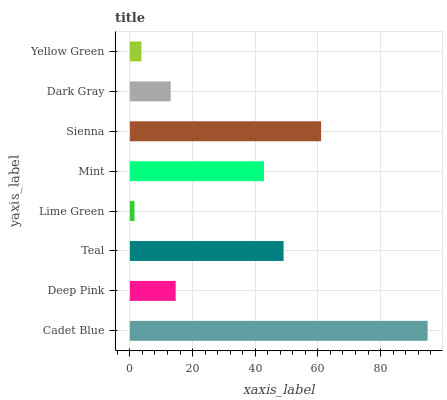Is Lime Green the minimum?
Answer yes or no. Yes. Is Cadet Blue the maximum?
Answer yes or no. Yes. Is Deep Pink the minimum?
Answer yes or no. No. Is Deep Pink the maximum?
Answer yes or no. No. Is Cadet Blue greater than Deep Pink?
Answer yes or no. Yes. Is Deep Pink less than Cadet Blue?
Answer yes or no. Yes. Is Deep Pink greater than Cadet Blue?
Answer yes or no. No. Is Cadet Blue less than Deep Pink?
Answer yes or no. No. Is Mint the high median?
Answer yes or no. Yes. Is Deep Pink the low median?
Answer yes or no. Yes. Is Dark Gray the high median?
Answer yes or no. No. Is Yellow Green the low median?
Answer yes or no. No. 